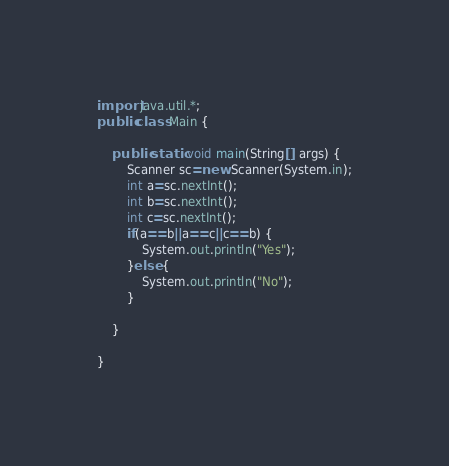Convert code to text. <code><loc_0><loc_0><loc_500><loc_500><_Java_>import java.util.*;
public class Main {

	public static void main(String[] args) {
		Scanner sc=new Scanner(System.in);
		int a=sc.nextInt();
		int b=sc.nextInt();
		int c=sc.nextInt();
		if(a==b||a==c||c==b) {
			System.out.println("Yes");
		}else {
			System.out.println("No");
		}

	}

}
</code> 